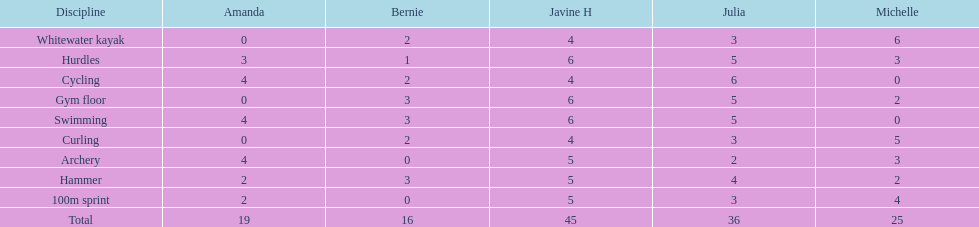Who accumulated the highest overall points? Javine H. 